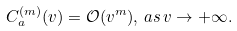<formula> <loc_0><loc_0><loc_500><loc_500>C _ { a } ^ { ( m ) } ( v ) = \mathcal { O } ( v ^ { m } ) , \, a s \, v \to + \infty .</formula> 